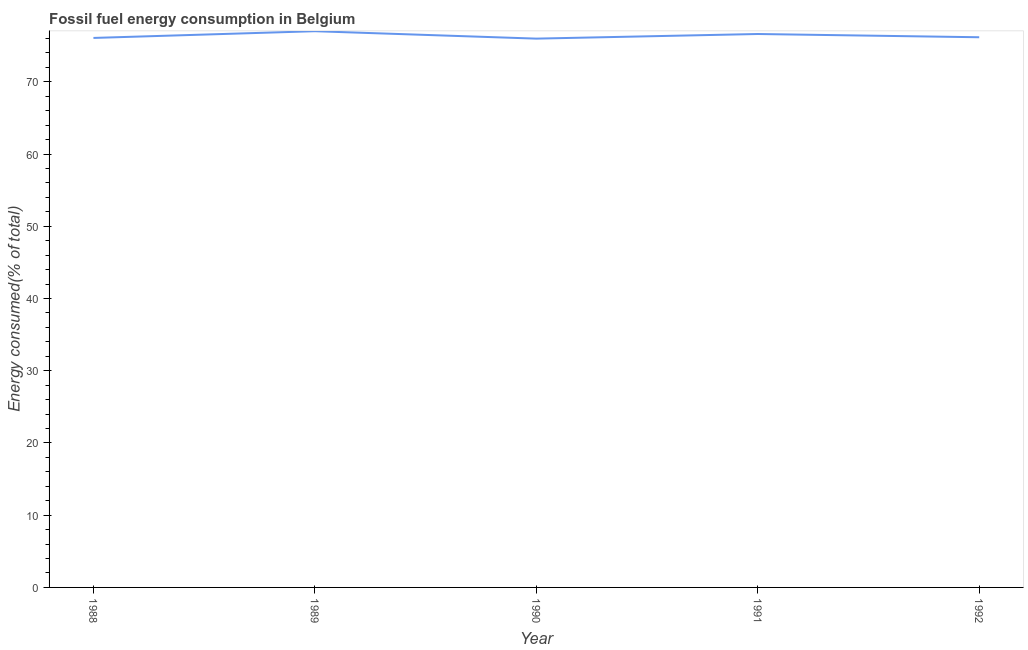What is the fossil fuel energy consumption in 1991?
Give a very brief answer. 76.63. Across all years, what is the maximum fossil fuel energy consumption?
Your answer should be very brief. 77.02. Across all years, what is the minimum fossil fuel energy consumption?
Offer a very short reply. 75.99. In which year was the fossil fuel energy consumption minimum?
Your response must be concise. 1990. What is the sum of the fossil fuel energy consumption?
Your response must be concise. 381.9. What is the difference between the fossil fuel energy consumption in 1988 and 1990?
Your response must be concise. 0.1. What is the average fossil fuel energy consumption per year?
Provide a succinct answer. 76.38. What is the median fossil fuel energy consumption?
Make the answer very short. 76.18. In how many years, is the fossil fuel energy consumption greater than 48 %?
Give a very brief answer. 5. Do a majority of the years between 1991 and 1992 (inclusive) have fossil fuel energy consumption greater than 4 %?
Keep it short and to the point. Yes. What is the ratio of the fossil fuel energy consumption in 1988 to that in 1990?
Your answer should be very brief. 1. Is the difference between the fossil fuel energy consumption in 1989 and 1992 greater than the difference between any two years?
Provide a succinct answer. No. What is the difference between the highest and the second highest fossil fuel energy consumption?
Provide a succinct answer. 0.39. What is the difference between the highest and the lowest fossil fuel energy consumption?
Keep it short and to the point. 1.03. In how many years, is the fossil fuel energy consumption greater than the average fossil fuel energy consumption taken over all years?
Ensure brevity in your answer.  2. Does the fossil fuel energy consumption monotonically increase over the years?
Give a very brief answer. No. Does the graph contain any zero values?
Make the answer very short. No. Does the graph contain grids?
Offer a very short reply. No. What is the title of the graph?
Provide a succinct answer. Fossil fuel energy consumption in Belgium. What is the label or title of the X-axis?
Your answer should be very brief. Year. What is the label or title of the Y-axis?
Offer a very short reply. Energy consumed(% of total). What is the Energy consumed(% of total) of 1988?
Your answer should be very brief. 76.09. What is the Energy consumed(% of total) of 1989?
Give a very brief answer. 77.02. What is the Energy consumed(% of total) of 1990?
Keep it short and to the point. 75.99. What is the Energy consumed(% of total) of 1991?
Offer a terse response. 76.63. What is the Energy consumed(% of total) in 1992?
Offer a very short reply. 76.18. What is the difference between the Energy consumed(% of total) in 1988 and 1989?
Your answer should be very brief. -0.93. What is the difference between the Energy consumed(% of total) in 1988 and 1990?
Give a very brief answer. 0.1. What is the difference between the Energy consumed(% of total) in 1988 and 1991?
Offer a very short reply. -0.55. What is the difference between the Energy consumed(% of total) in 1988 and 1992?
Your answer should be compact. -0.09. What is the difference between the Energy consumed(% of total) in 1989 and 1990?
Ensure brevity in your answer.  1.03. What is the difference between the Energy consumed(% of total) in 1989 and 1991?
Ensure brevity in your answer.  0.39. What is the difference between the Energy consumed(% of total) in 1989 and 1992?
Offer a terse response. 0.84. What is the difference between the Energy consumed(% of total) in 1990 and 1991?
Your answer should be compact. -0.64. What is the difference between the Energy consumed(% of total) in 1990 and 1992?
Provide a short and direct response. -0.19. What is the difference between the Energy consumed(% of total) in 1991 and 1992?
Your answer should be compact. 0.45. What is the ratio of the Energy consumed(% of total) in 1989 to that in 1990?
Ensure brevity in your answer.  1.01. What is the ratio of the Energy consumed(% of total) in 1989 to that in 1992?
Keep it short and to the point. 1.01. 